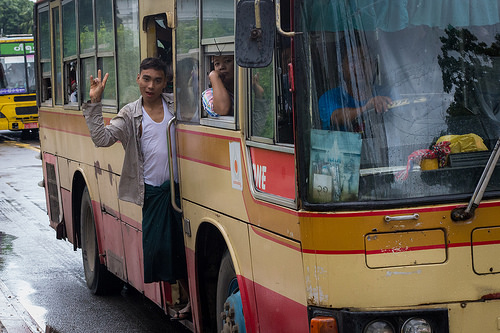<image>
Is the man on the road? No. The man is not positioned on the road. They may be near each other, but the man is not supported by or resting on top of the road. 